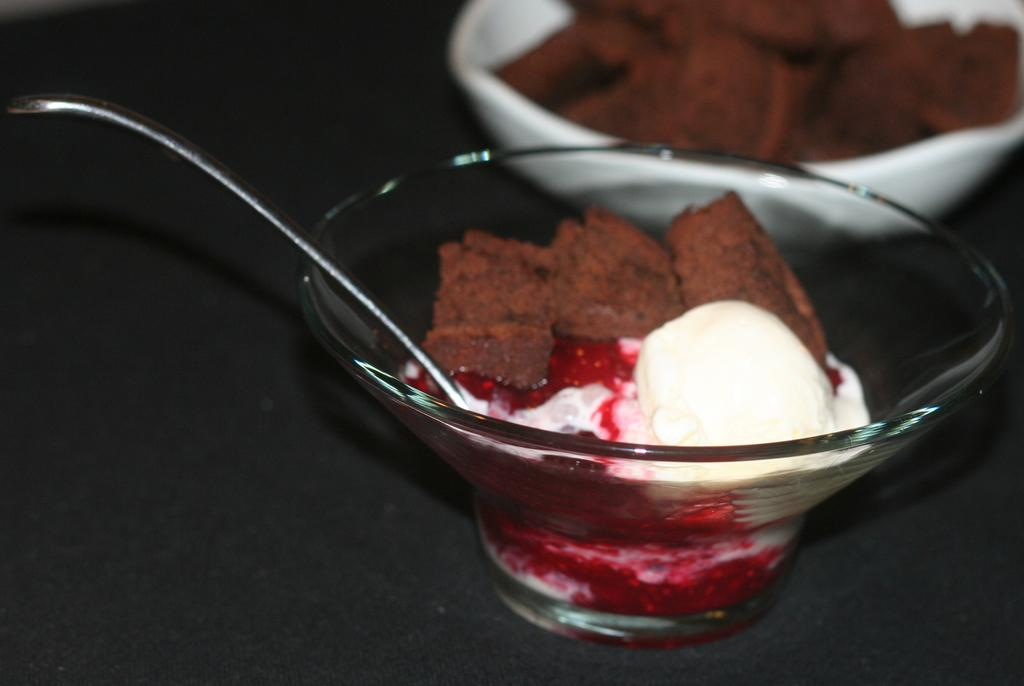What is the main subject of the image? The main subject of the image is an ice cream. What is used to eat the ice cream? There is a spoon in the image that can be used to eat the ice cream. How is the ice cream and spoon arranged in the image? The ice cream and spoon are placed in a glass bowl. What can be seen in the background of the image? In the background, there is food placed in a bowl. How many balls are bouncing around the ice cream in the image? There are no balls present in the image; it only features an ice cream, a spoon, and a glass bowl. 